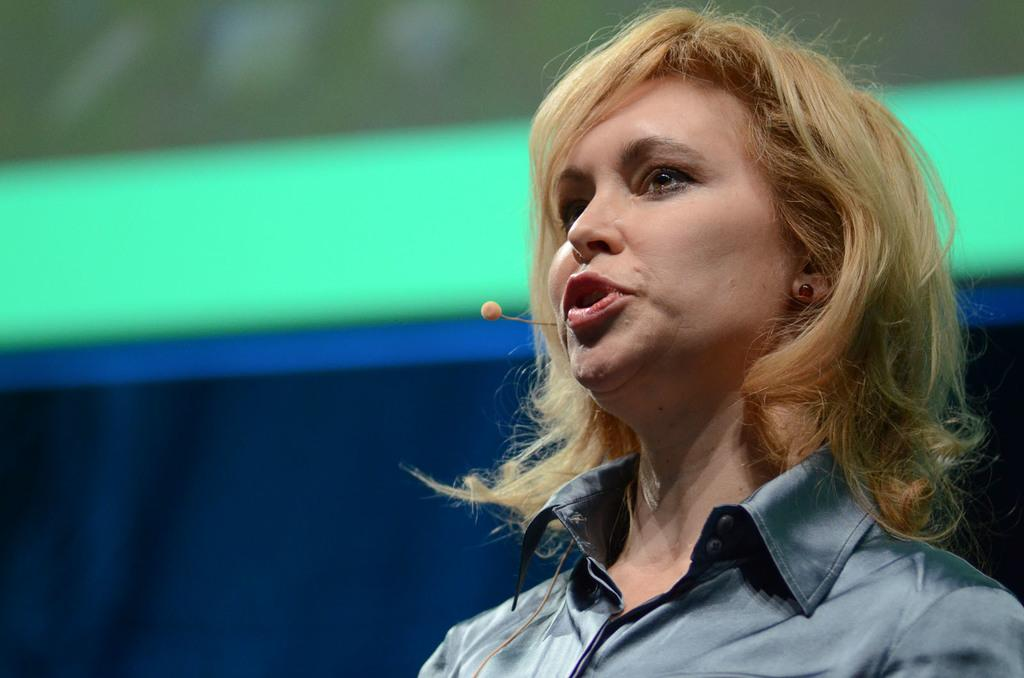What is the main subject of the image? There is a person in the image. Can you describe the background of the image? The background of the image has blue, white, and green colors. What is the title of the yam in the image? There is no yam present in the image, and therefore no title can be assigned to it. 